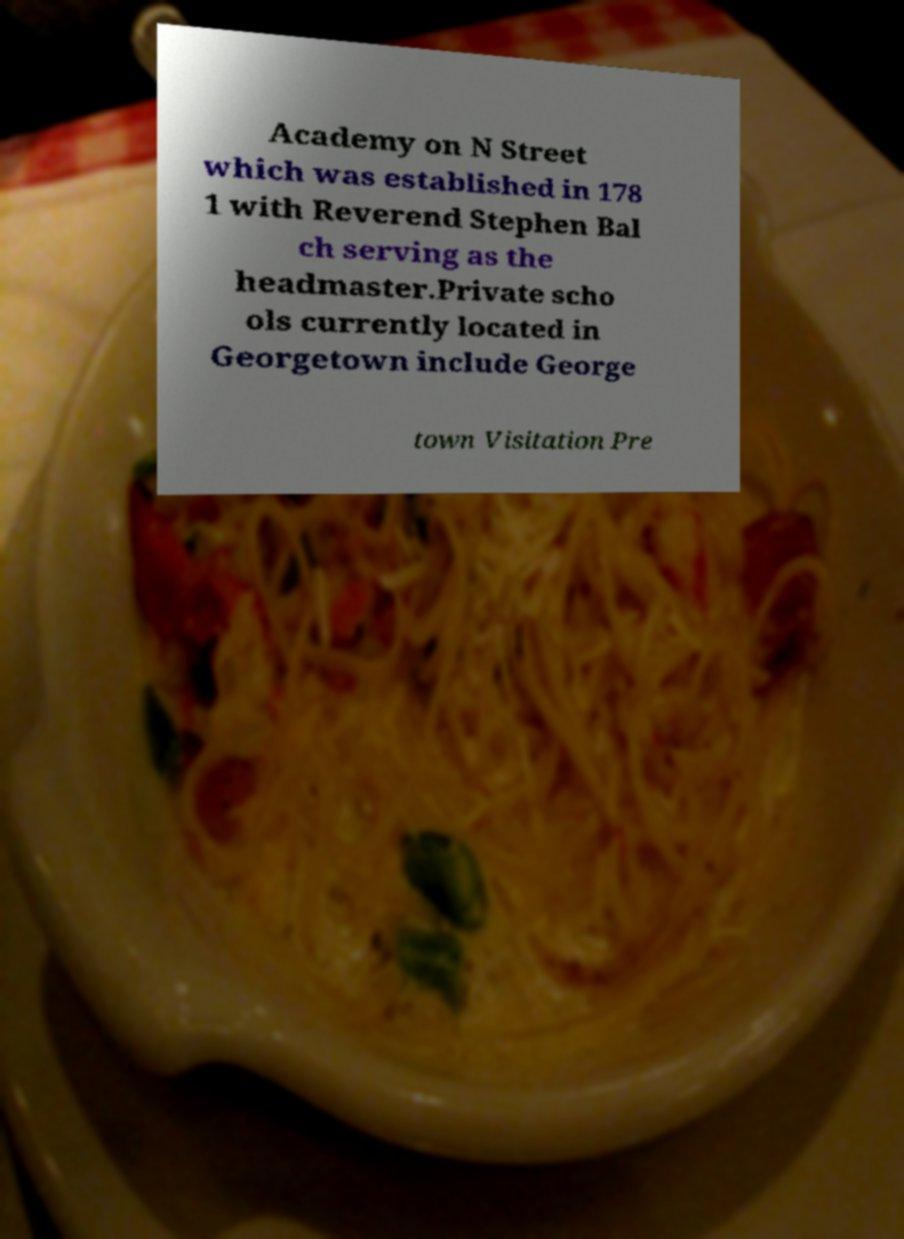For documentation purposes, I need the text within this image transcribed. Could you provide that? Academy on N Street which was established in 178 1 with Reverend Stephen Bal ch serving as the headmaster.Private scho ols currently located in Georgetown include George town Visitation Pre 